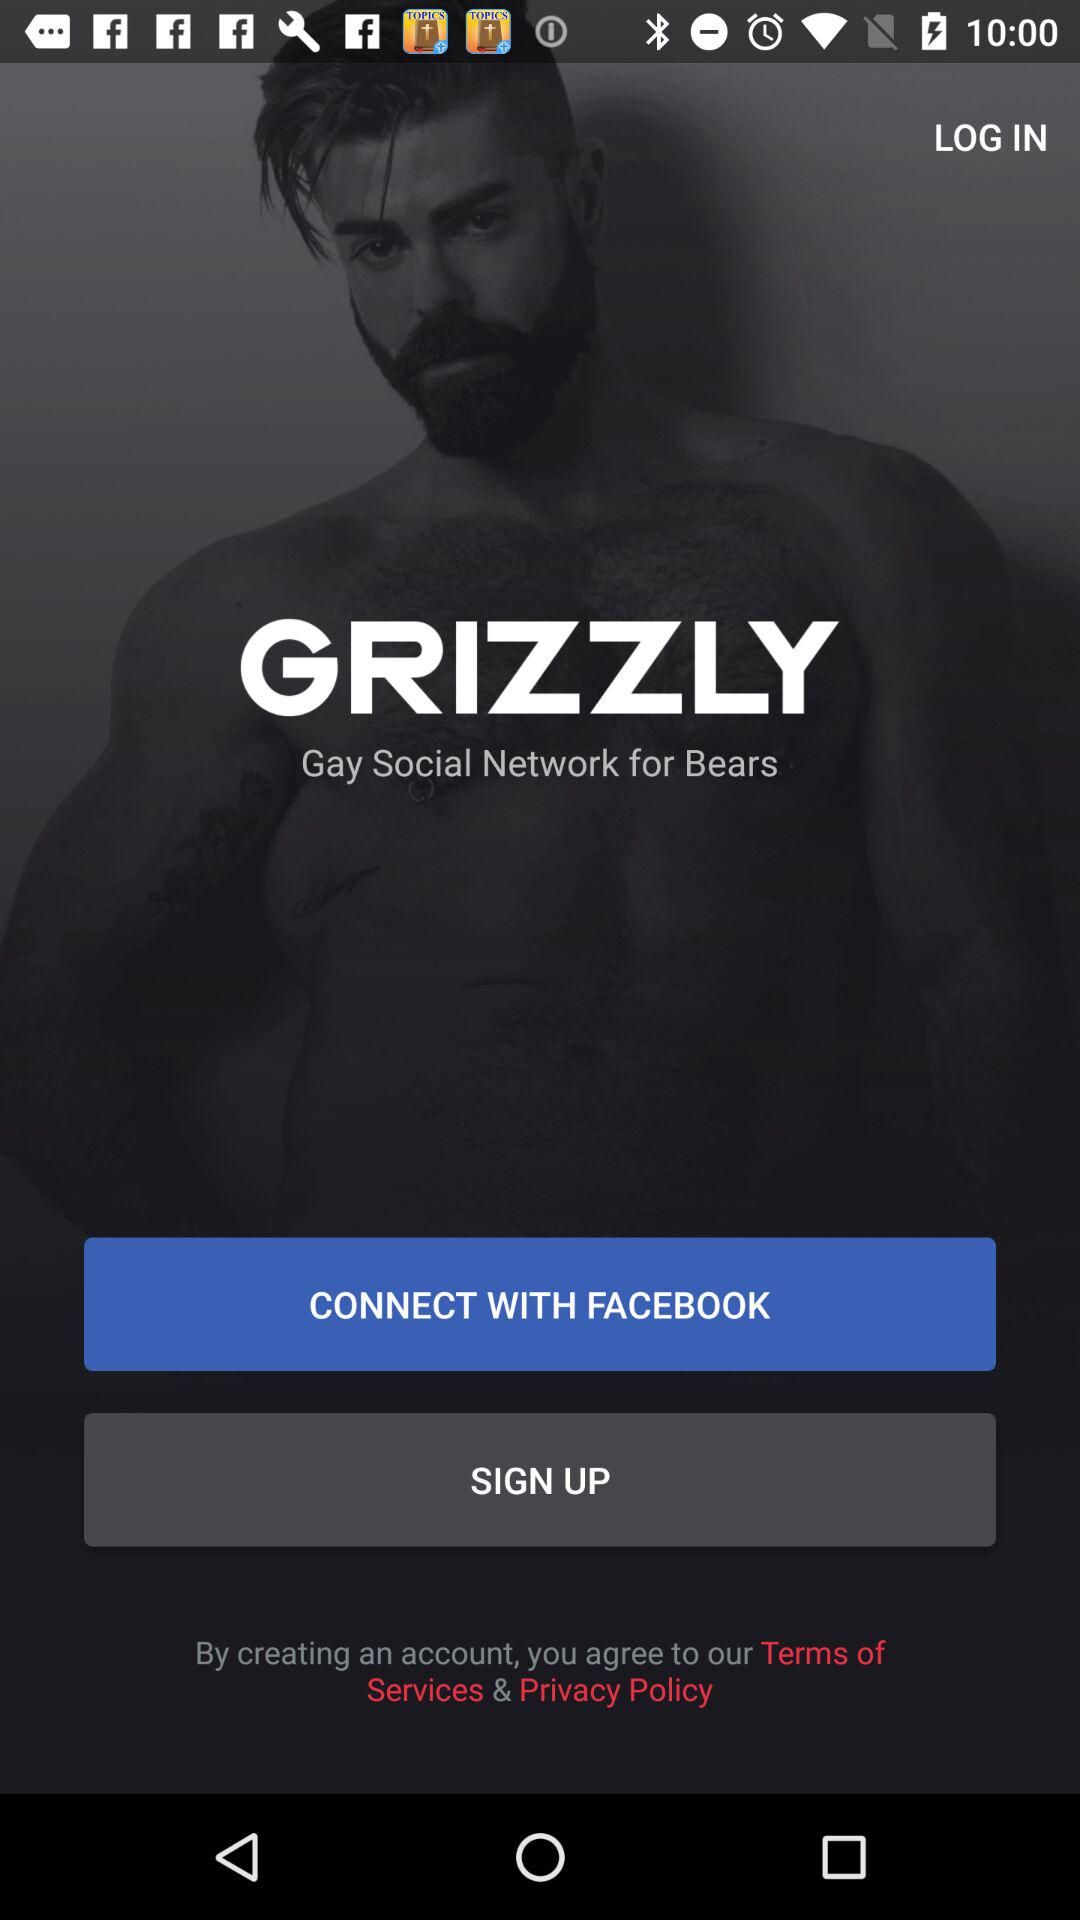What is the name of the application? The name of the application is "GRIZZLY". 